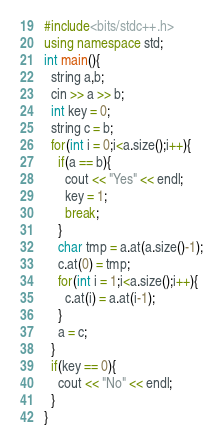Convert code to text. <code><loc_0><loc_0><loc_500><loc_500><_C++_>#include<bits/stdc++.h>
using namespace std;
int main(){
  string a,b;
  cin >> a >> b;
  int key = 0;
  string c = b;
  for(int i = 0;i<a.size();i++){
    if(a == b){
      cout << "Yes" << endl;
      key = 1;
      break;
    }
    char tmp = a.at(a.size()-1);
    c.at(0) = tmp;
    for(int i = 1;i<a.size();i++){
      c.at(i) = a.at(i-1);
    }
    a = c;
  }
  if(key == 0){
    cout << "No" << endl;
  }
}
</code> 